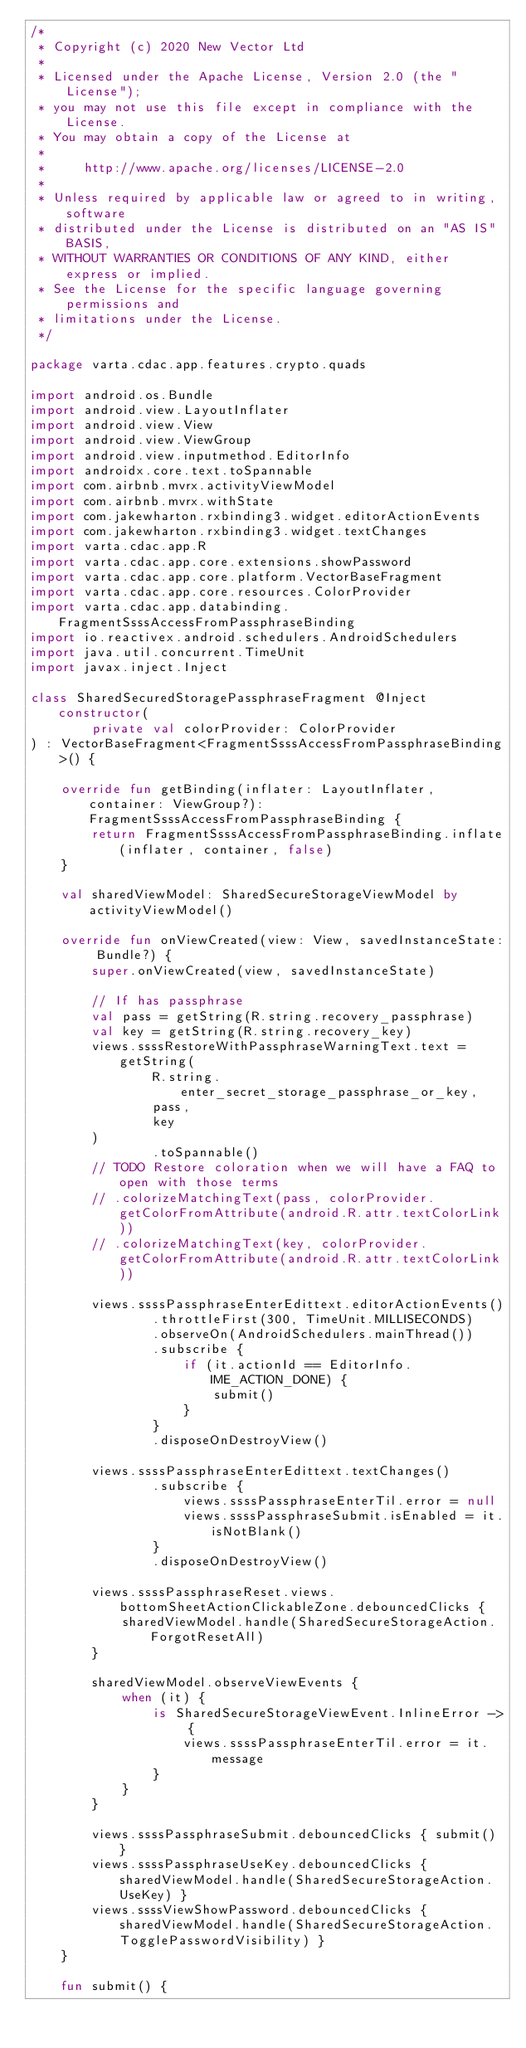<code> <loc_0><loc_0><loc_500><loc_500><_Kotlin_>/*
 * Copyright (c) 2020 New Vector Ltd
 *
 * Licensed under the Apache License, Version 2.0 (the "License");
 * you may not use this file except in compliance with the License.
 * You may obtain a copy of the License at
 *
 *     http://www.apache.org/licenses/LICENSE-2.0
 *
 * Unless required by applicable law or agreed to in writing, software
 * distributed under the License is distributed on an "AS IS" BASIS,
 * WITHOUT WARRANTIES OR CONDITIONS OF ANY KIND, either express or implied.
 * See the License for the specific language governing permissions and
 * limitations under the License.
 */

package varta.cdac.app.features.crypto.quads

import android.os.Bundle
import android.view.LayoutInflater
import android.view.View
import android.view.ViewGroup
import android.view.inputmethod.EditorInfo
import androidx.core.text.toSpannable
import com.airbnb.mvrx.activityViewModel
import com.airbnb.mvrx.withState
import com.jakewharton.rxbinding3.widget.editorActionEvents
import com.jakewharton.rxbinding3.widget.textChanges
import varta.cdac.app.R
import varta.cdac.app.core.extensions.showPassword
import varta.cdac.app.core.platform.VectorBaseFragment
import varta.cdac.app.core.resources.ColorProvider
import varta.cdac.app.databinding.FragmentSsssAccessFromPassphraseBinding
import io.reactivex.android.schedulers.AndroidSchedulers
import java.util.concurrent.TimeUnit
import javax.inject.Inject

class SharedSecuredStoragePassphraseFragment @Inject constructor(
        private val colorProvider: ColorProvider
) : VectorBaseFragment<FragmentSsssAccessFromPassphraseBinding>() {

    override fun getBinding(inflater: LayoutInflater, container: ViewGroup?): FragmentSsssAccessFromPassphraseBinding {
        return FragmentSsssAccessFromPassphraseBinding.inflate(inflater, container, false)
    }

    val sharedViewModel: SharedSecureStorageViewModel by activityViewModel()

    override fun onViewCreated(view: View, savedInstanceState: Bundle?) {
        super.onViewCreated(view, savedInstanceState)

        // If has passphrase
        val pass = getString(R.string.recovery_passphrase)
        val key = getString(R.string.recovery_key)
        views.ssssRestoreWithPassphraseWarningText.text = getString(
                R.string.enter_secret_storage_passphrase_or_key,
                pass,
                key
        )
                .toSpannable()
        // TODO Restore coloration when we will have a FAQ to open with those terms
        // .colorizeMatchingText(pass, colorProvider.getColorFromAttribute(android.R.attr.textColorLink))
        // .colorizeMatchingText(key, colorProvider.getColorFromAttribute(android.R.attr.textColorLink))

        views.ssssPassphraseEnterEdittext.editorActionEvents()
                .throttleFirst(300, TimeUnit.MILLISECONDS)
                .observeOn(AndroidSchedulers.mainThread())
                .subscribe {
                    if (it.actionId == EditorInfo.IME_ACTION_DONE) {
                        submit()
                    }
                }
                .disposeOnDestroyView()

        views.ssssPassphraseEnterEdittext.textChanges()
                .subscribe {
                    views.ssssPassphraseEnterTil.error = null
                    views.ssssPassphraseSubmit.isEnabled = it.isNotBlank()
                }
                .disposeOnDestroyView()

        views.ssssPassphraseReset.views.bottomSheetActionClickableZone.debouncedClicks {
            sharedViewModel.handle(SharedSecureStorageAction.ForgotResetAll)
        }

        sharedViewModel.observeViewEvents {
            when (it) {
                is SharedSecureStorageViewEvent.InlineError -> {
                    views.ssssPassphraseEnterTil.error = it.message
                }
            }
        }

        views.ssssPassphraseSubmit.debouncedClicks { submit() }
        views.ssssPassphraseUseKey.debouncedClicks { sharedViewModel.handle(SharedSecureStorageAction.UseKey) }
        views.ssssViewShowPassword.debouncedClicks { sharedViewModel.handle(SharedSecureStorageAction.TogglePasswordVisibility) }
    }

    fun submit() {</code> 